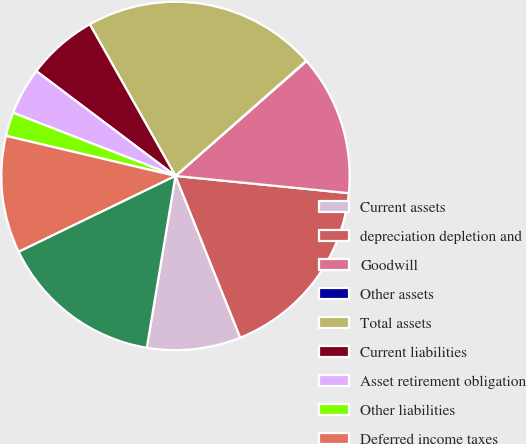Convert chart. <chart><loc_0><loc_0><loc_500><loc_500><pie_chart><fcel>Current assets<fcel>depreciation depletion and<fcel>Goodwill<fcel>Other assets<fcel>Total assets<fcel>Current liabilities<fcel>Asset retirement obligation<fcel>Other liabilities<fcel>Deferred income taxes<fcel>Stockholders' equity<nl><fcel>8.7%<fcel>17.36%<fcel>13.03%<fcel>0.04%<fcel>21.69%<fcel>6.54%<fcel>4.37%<fcel>2.21%<fcel>10.87%<fcel>15.19%<nl></chart> 